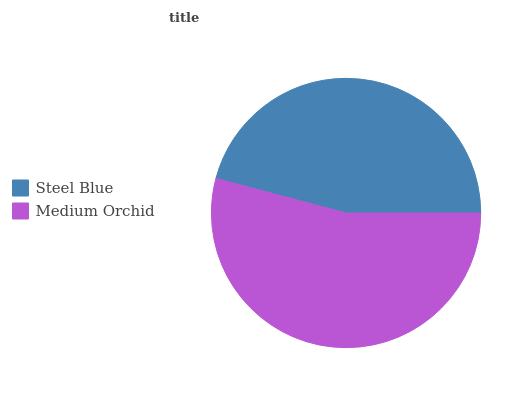Is Steel Blue the minimum?
Answer yes or no. Yes. Is Medium Orchid the maximum?
Answer yes or no. Yes. Is Medium Orchid the minimum?
Answer yes or no. No. Is Medium Orchid greater than Steel Blue?
Answer yes or no. Yes. Is Steel Blue less than Medium Orchid?
Answer yes or no. Yes. Is Steel Blue greater than Medium Orchid?
Answer yes or no. No. Is Medium Orchid less than Steel Blue?
Answer yes or no. No. Is Medium Orchid the high median?
Answer yes or no. Yes. Is Steel Blue the low median?
Answer yes or no. Yes. Is Steel Blue the high median?
Answer yes or no. No. Is Medium Orchid the low median?
Answer yes or no. No. 